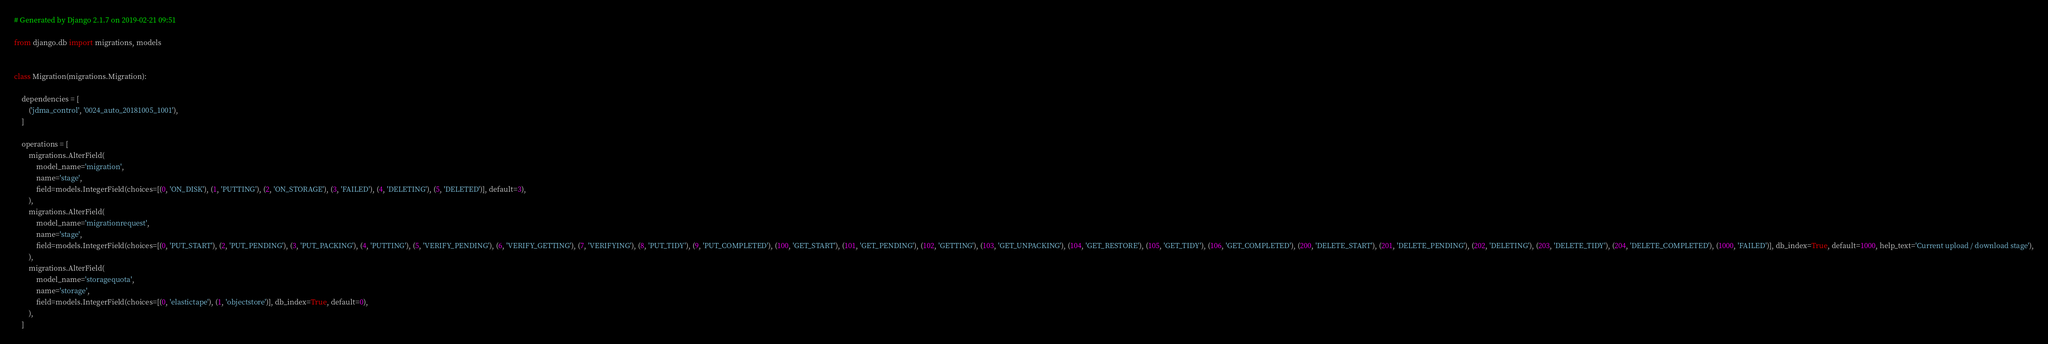Convert code to text. <code><loc_0><loc_0><loc_500><loc_500><_Python_># Generated by Django 2.1.7 on 2019-02-21 09:51

from django.db import migrations, models


class Migration(migrations.Migration):

    dependencies = [
        ('jdma_control', '0024_auto_20181005_1001'),
    ]

    operations = [
        migrations.AlterField(
            model_name='migration',
            name='stage',
            field=models.IntegerField(choices=[(0, 'ON_DISK'), (1, 'PUTTING'), (2, 'ON_STORAGE'), (3, 'FAILED'), (4, 'DELETING'), (5, 'DELETED')], default=3),
        ),
        migrations.AlterField(
            model_name='migrationrequest',
            name='stage',
            field=models.IntegerField(choices=[(0, 'PUT_START'), (2, 'PUT_PENDING'), (3, 'PUT_PACKING'), (4, 'PUTTING'), (5, 'VERIFY_PENDING'), (6, 'VERIFY_GETTING'), (7, 'VERIFYING'), (8, 'PUT_TIDY'), (9, 'PUT_COMPLETED'), (100, 'GET_START'), (101, 'GET_PENDING'), (102, 'GETTING'), (103, 'GET_UNPACKING'), (104, 'GET_RESTORE'), (105, 'GET_TIDY'), (106, 'GET_COMPLETED'), (200, 'DELETE_START'), (201, 'DELETE_PENDING'), (202, 'DELETING'), (203, 'DELETE_TIDY'), (204, 'DELETE_COMPLETED'), (1000, 'FAILED')], db_index=True, default=1000, help_text='Current upload / download stage'),
        ),
        migrations.AlterField(
            model_name='storagequota',
            name='storage',
            field=models.IntegerField(choices=[(0, 'elastictape'), (1, 'objectstore')], db_index=True, default=0),
        ),
    ]
</code> 